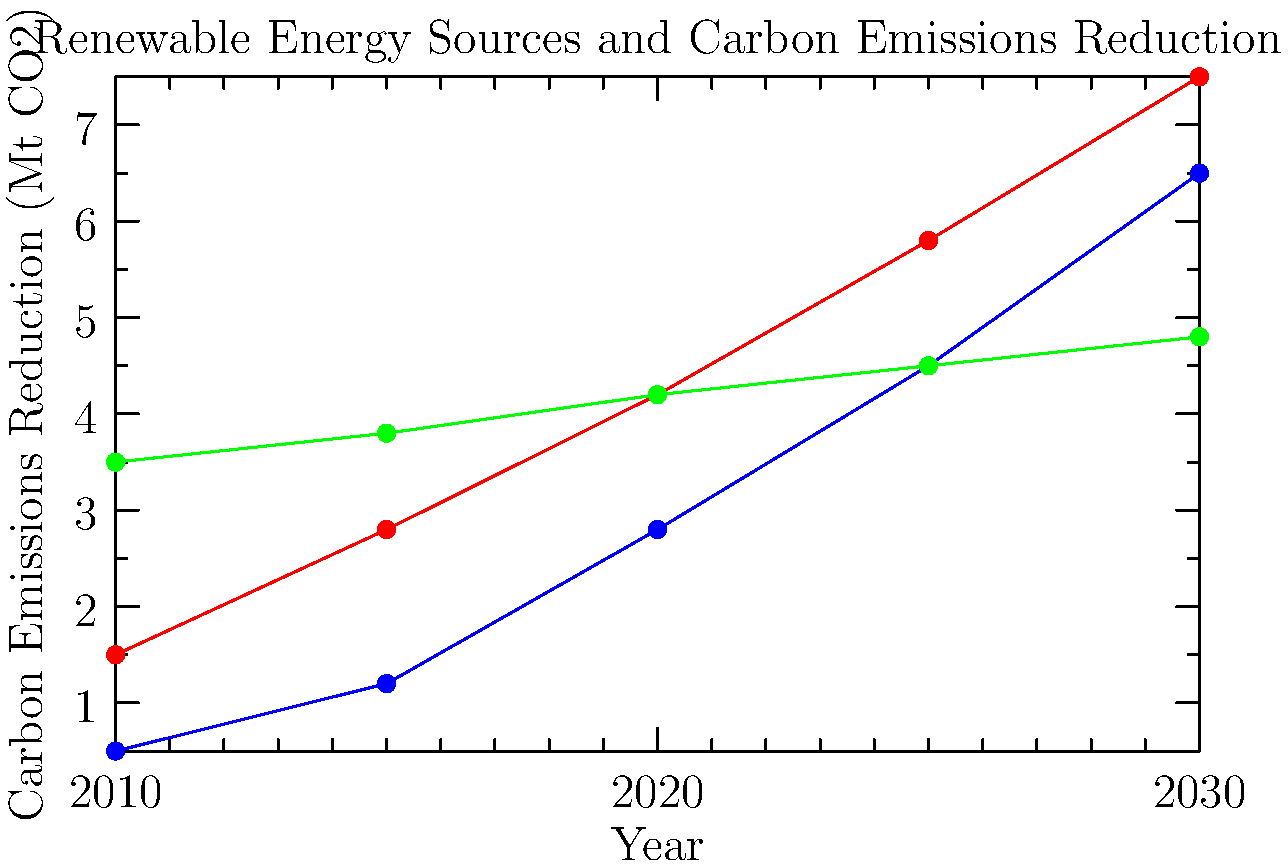Based on the line graph showing the projected carbon emissions reduction for different renewable energy sources in England from 2010 to 2030, which source is expected to have the highest rate of growth in emissions reduction, and what environmental law implications might this have for local communities? To answer this question, we need to analyze the graph and consider the environmental law implications:

1. Examine the slopes of each line:
   - Solar (blue): Steepest increase
   - Wind (red): Moderate increase
   - Hydro (green): Slight increase

2. Calculate the rate of growth for each source from 2010 to 2030:
   - Solar: $(6.5 - 0.5) / 0.5 = 1200\%$ increase
   - Wind: $(7.5 - 1.5) / 1.5 = 400\%$ increase
   - Hydro: $(4.8 - 3.5) / 3.5 = 37.1\%$ increase

3. Identify the highest rate of growth: Solar energy has the highest rate at 1200%.

4. Environmental law implications for local communities:
   a) Increased demand for land use planning and zoning regulations to accommodate solar farms.
   b) Potential conflicts with existing land use and conservation laws.
   c) Need for new local ordinances to regulate solar panel installation on buildings.
   d) Possible amendments to environmental impact assessment requirements for solar projects.
   e) Opportunities for community-based solar initiatives, requiring new legal frameworks.
   f) Potential changes in air quality regulations as traditional power sources are phased out.

5. As a concerned local resident specializing in environmental law, you might focus on:
   - Ensuring fair and sustainable implementation of solar projects.
   - Advocating for balanced regulations that promote solar energy while protecting local ecosystems and communities.
   - Developing legal frameworks for community ownership of solar projects.
   - Addressing potential environmental justice issues related to the distribution of solar installations.
Answer: Solar energy, with implications for land use planning, zoning regulations, and community-based energy initiatives. 